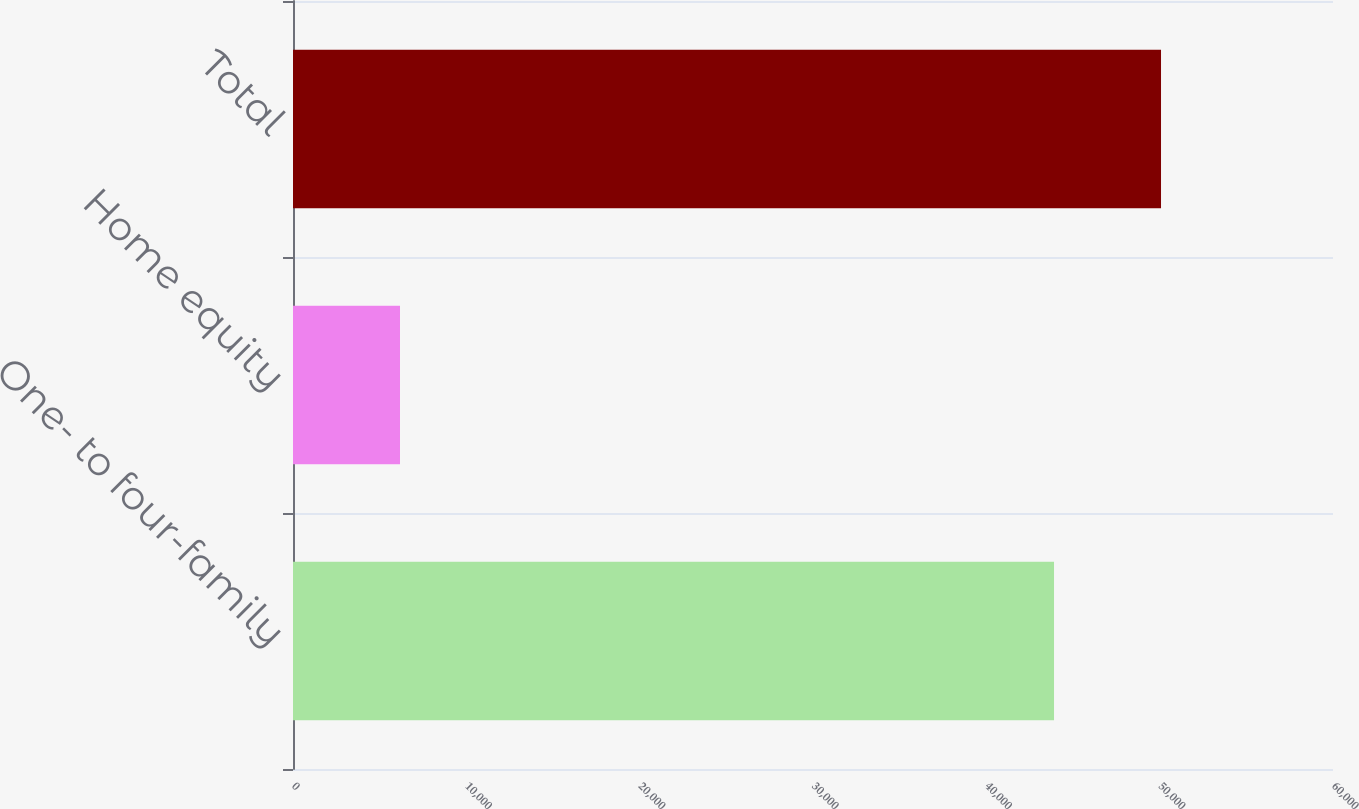<chart> <loc_0><loc_0><loc_500><loc_500><bar_chart><fcel>One- to four-family<fcel>Home equity<fcel>Total<nl><fcel>43905<fcel>6173<fcel>50078<nl></chart> 